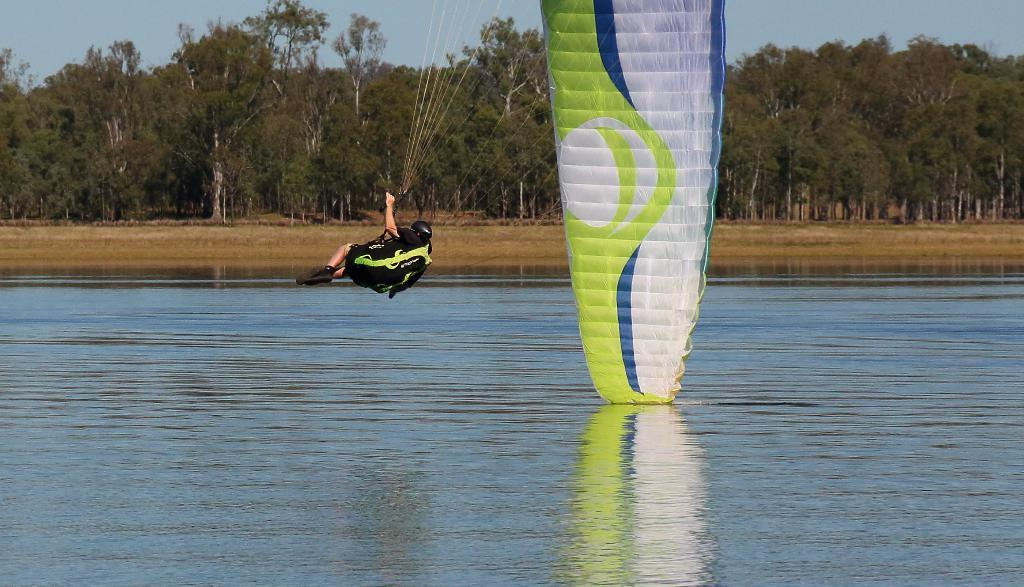What is the man in the picture doing? The man is paragliding in the picture. What is the man's activity taking place over? The man is paragliding over water, which might be in a lake. What can be seen in the background of the image? There are trees in the background of the image. What is visible at the top of the image? The sky is visible at the top of the image. What type of detail is the man wearing on his arm while paragliding? There is no mention of any specific detail on the man's arm in the image. Can you tell me if the man is a lawyer based on the image? There is no information about the man's profession in the image, so it cannot be determined if he is a lawyer. Is the man playing basketball while paragliding in the image? No, the man is paragliding, not playing basketball, in the image. 